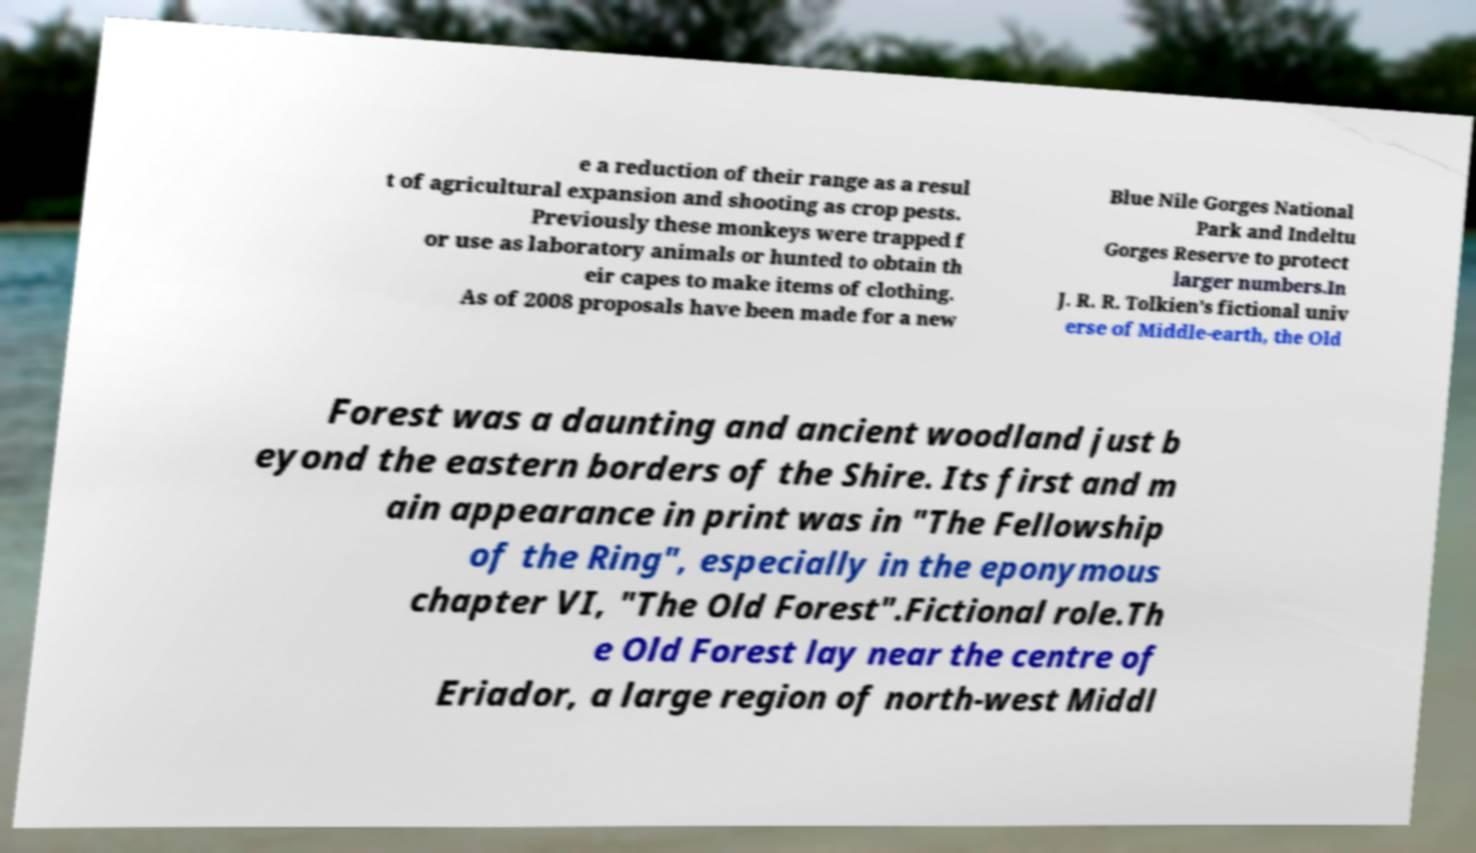Could you assist in decoding the text presented in this image and type it out clearly? e a reduction of their range as a resul t of agricultural expansion and shooting as crop pests. Previously these monkeys were trapped f or use as laboratory animals or hunted to obtain th eir capes to make items of clothing. As of 2008 proposals have been made for a new Blue Nile Gorges National Park and Indeltu Gorges Reserve to protect larger numbers.In J. R. R. Tolkien’s fictional univ erse of Middle-earth, the Old Forest was a daunting and ancient woodland just b eyond the eastern borders of the Shire. Its first and m ain appearance in print was in "The Fellowship of the Ring", especially in the eponymous chapter VI, "The Old Forest".Fictional role.Th e Old Forest lay near the centre of Eriador, a large region of north-west Middl 